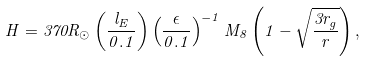Convert formula to latex. <formula><loc_0><loc_0><loc_500><loc_500>H = 3 7 0 R _ { \odot } \left ( \frac { l _ { E } } { 0 . 1 } \right ) \left ( \frac { \epsilon } { 0 . 1 } \right ) ^ { - 1 } M _ { 8 } \left ( 1 - \sqrt { \frac { 3 r _ { g } } { r } } \right ) ,</formula> 